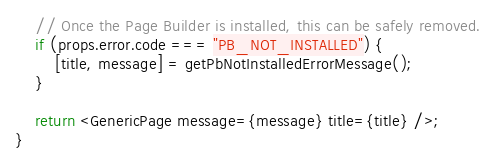Convert code to text. <code><loc_0><loc_0><loc_500><loc_500><_JavaScript_>
    // Once the Page Builder is installed, this can be safely removed.
    if (props.error.code === "PB_NOT_INSTALLED") {
        [title, message] = getPbNotInstalledErrorMessage();
    }

    return <GenericPage message={message} title={title} />;
}
</code> 